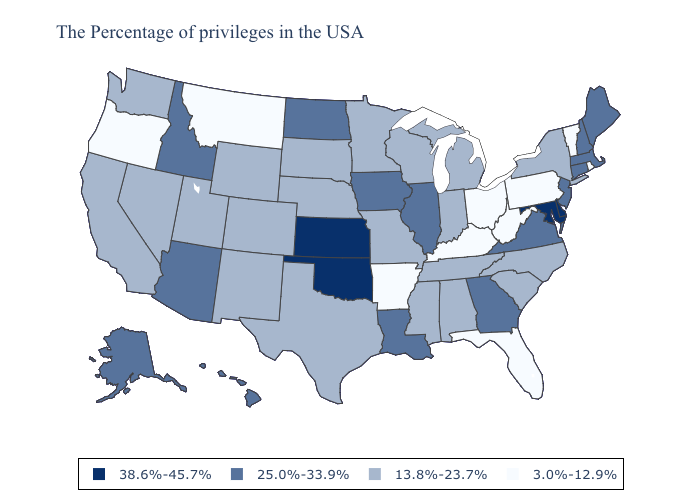What is the value of Michigan?
Concise answer only. 13.8%-23.7%. Name the states that have a value in the range 25.0%-33.9%?
Write a very short answer. Maine, Massachusetts, New Hampshire, Connecticut, New Jersey, Virginia, Georgia, Illinois, Louisiana, Iowa, North Dakota, Arizona, Idaho, Alaska, Hawaii. Name the states that have a value in the range 38.6%-45.7%?
Concise answer only. Delaware, Maryland, Kansas, Oklahoma. Which states have the highest value in the USA?
Answer briefly. Delaware, Maryland, Kansas, Oklahoma. What is the lowest value in the Northeast?
Short answer required. 3.0%-12.9%. Name the states that have a value in the range 13.8%-23.7%?
Quick response, please. New York, North Carolina, South Carolina, Michigan, Indiana, Alabama, Tennessee, Wisconsin, Mississippi, Missouri, Minnesota, Nebraska, Texas, South Dakota, Wyoming, Colorado, New Mexico, Utah, Nevada, California, Washington. Does Tennessee have the same value as Iowa?
Answer briefly. No. Does the map have missing data?
Concise answer only. No. Among the states that border Tennessee , which have the highest value?
Answer briefly. Virginia, Georgia. What is the lowest value in the USA?
Give a very brief answer. 3.0%-12.9%. Is the legend a continuous bar?
Write a very short answer. No. What is the value of Missouri?
Quick response, please. 13.8%-23.7%. Name the states that have a value in the range 3.0%-12.9%?
Answer briefly. Rhode Island, Vermont, Pennsylvania, West Virginia, Ohio, Florida, Kentucky, Arkansas, Montana, Oregon. What is the lowest value in states that border Alabama?
Quick response, please. 3.0%-12.9%. What is the value of West Virginia?
Write a very short answer. 3.0%-12.9%. 